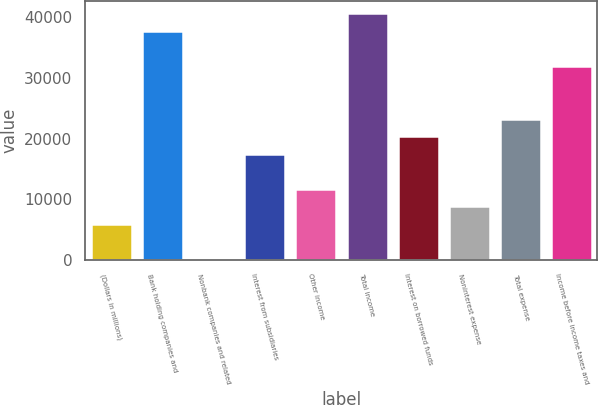Convert chart. <chart><loc_0><loc_0><loc_500><loc_500><bar_chart><fcel>(Dollars in millions)<fcel>Bank holding companies and<fcel>Nonbank companies and related<fcel>Interest from subsidiaries<fcel>Other income<fcel>Total income<fcel>Interest on borrowed funds<fcel>Noninterest expense<fcel>Total expense<fcel>Income before income taxes and<nl><fcel>5955.6<fcel>37715.9<fcel>181<fcel>17504.8<fcel>11730.2<fcel>40603.2<fcel>20392.1<fcel>8842.9<fcel>23279.4<fcel>31941.3<nl></chart> 